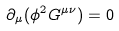<formula> <loc_0><loc_0><loc_500><loc_500>\partial _ { \mu } ( \phi ^ { 2 } G ^ { \mu \nu } ) = 0</formula> 